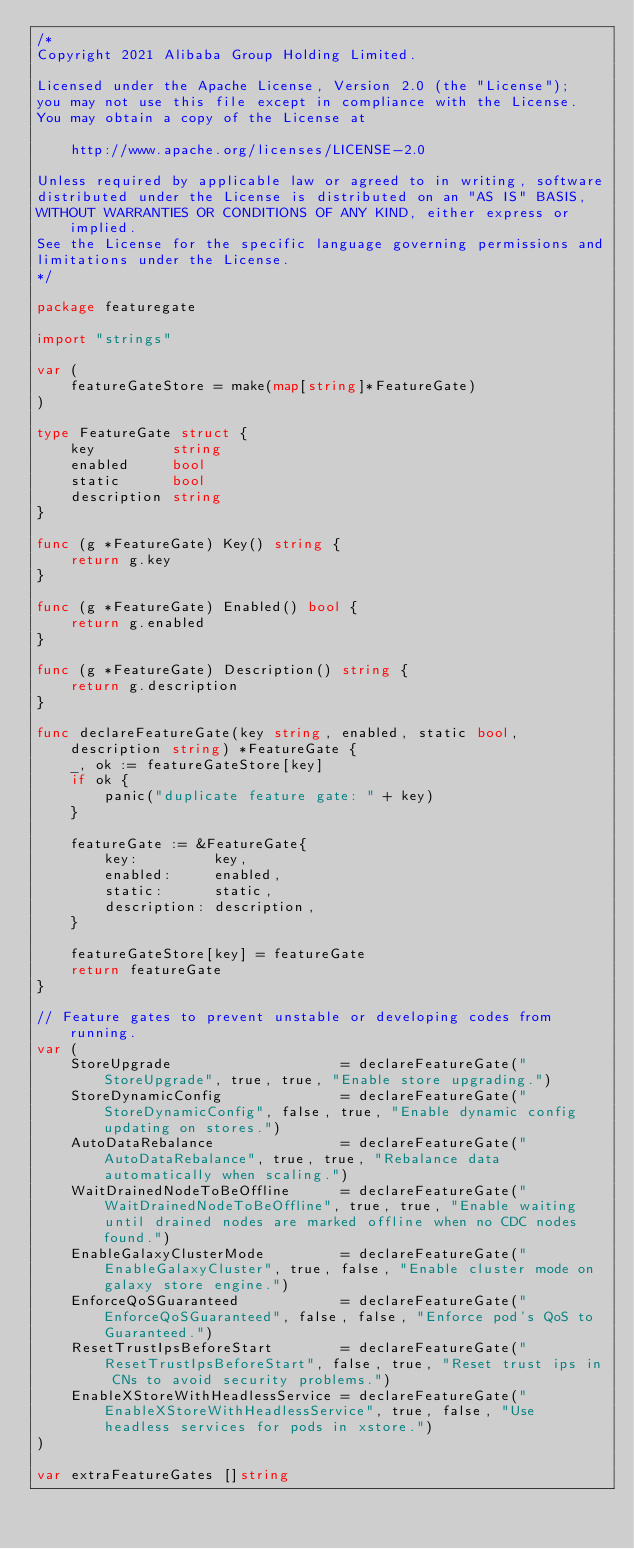<code> <loc_0><loc_0><loc_500><loc_500><_Go_>/*
Copyright 2021 Alibaba Group Holding Limited.

Licensed under the Apache License, Version 2.0 (the "License");
you may not use this file except in compliance with the License.
You may obtain a copy of the License at

    http://www.apache.org/licenses/LICENSE-2.0

Unless required by applicable law or agreed to in writing, software
distributed under the License is distributed on an "AS IS" BASIS,
WITHOUT WARRANTIES OR CONDITIONS OF ANY KIND, either express or implied.
See the License for the specific language governing permissions and
limitations under the License.
*/

package featuregate

import "strings"

var (
	featureGateStore = make(map[string]*FeatureGate)
)

type FeatureGate struct {
	key         string
	enabled     bool
	static      bool
	description string
}

func (g *FeatureGate) Key() string {
	return g.key
}

func (g *FeatureGate) Enabled() bool {
	return g.enabled
}

func (g *FeatureGate) Description() string {
	return g.description
}

func declareFeatureGate(key string, enabled, static bool, description string) *FeatureGate {
	_, ok := featureGateStore[key]
	if ok {
		panic("duplicate feature gate: " + key)
	}

	featureGate := &FeatureGate{
		key:         key,
		enabled:     enabled,
		static:      static,
		description: description,
	}

	featureGateStore[key] = featureGate
	return featureGate
}

// Feature gates to prevent unstable or developing codes from running.
var (
	StoreUpgrade                    = declareFeatureGate("StoreUpgrade", true, true, "Enable store upgrading.")
	StoreDynamicConfig              = declareFeatureGate("StoreDynamicConfig", false, true, "Enable dynamic config updating on stores.")
	AutoDataRebalance               = declareFeatureGate("AutoDataRebalance", true, true, "Rebalance data automatically when scaling.")
	WaitDrainedNodeToBeOffline      = declareFeatureGate("WaitDrainedNodeToBeOffline", true, true, "Enable waiting until drained nodes are marked offline when no CDC nodes found.")
	EnableGalaxyClusterMode         = declareFeatureGate("EnableGalaxyCluster", true, false, "Enable cluster mode on galaxy store engine.")
	EnforceQoSGuaranteed            = declareFeatureGate("EnforceQoSGuaranteed", false, false, "Enforce pod's QoS to Guaranteed.")
	ResetTrustIpsBeforeStart        = declareFeatureGate("ResetTrustIpsBeforeStart", false, true, "Reset trust ips in CNs to avoid security problems.")
	EnableXStoreWithHeadlessService = declareFeatureGate("EnableXStoreWithHeadlessService", true, false, "Use headless services for pods in xstore.")
)

var extraFeatureGates []string
</code> 